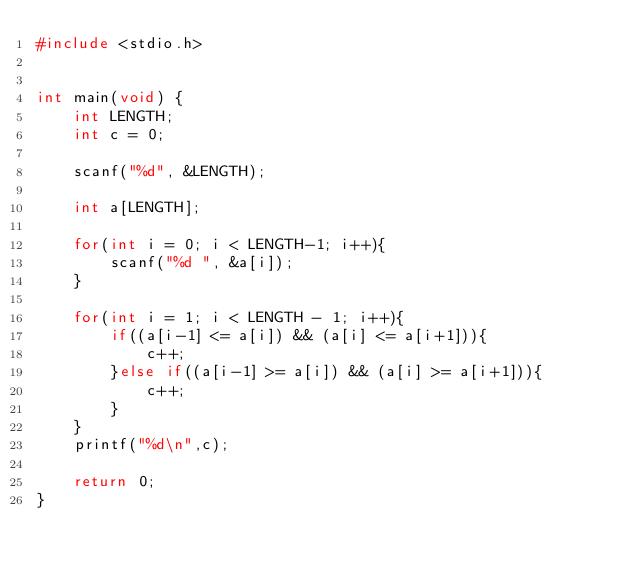<code> <loc_0><loc_0><loc_500><loc_500><_C_>#include <stdio.h>


int main(void) {
    int LENGTH;
    int c = 0;

    scanf("%d", &LENGTH);

    int a[LENGTH];
    
    for(int i = 0; i < LENGTH-1; i++){
        scanf("%d ", &a[i]);
    }

    for(int i = 1; i < LENGTH - 1; i++){
        if((a[i-1] <= a[i]) && (a[i] <= a[i+1])){
            c++;
        }else if((a[i-1] >= a[i]) && (a[i] >= a[i+1])){
            c++;
        }
    }
    printf("%d\n",c);
    
    return 0;
}</code> 